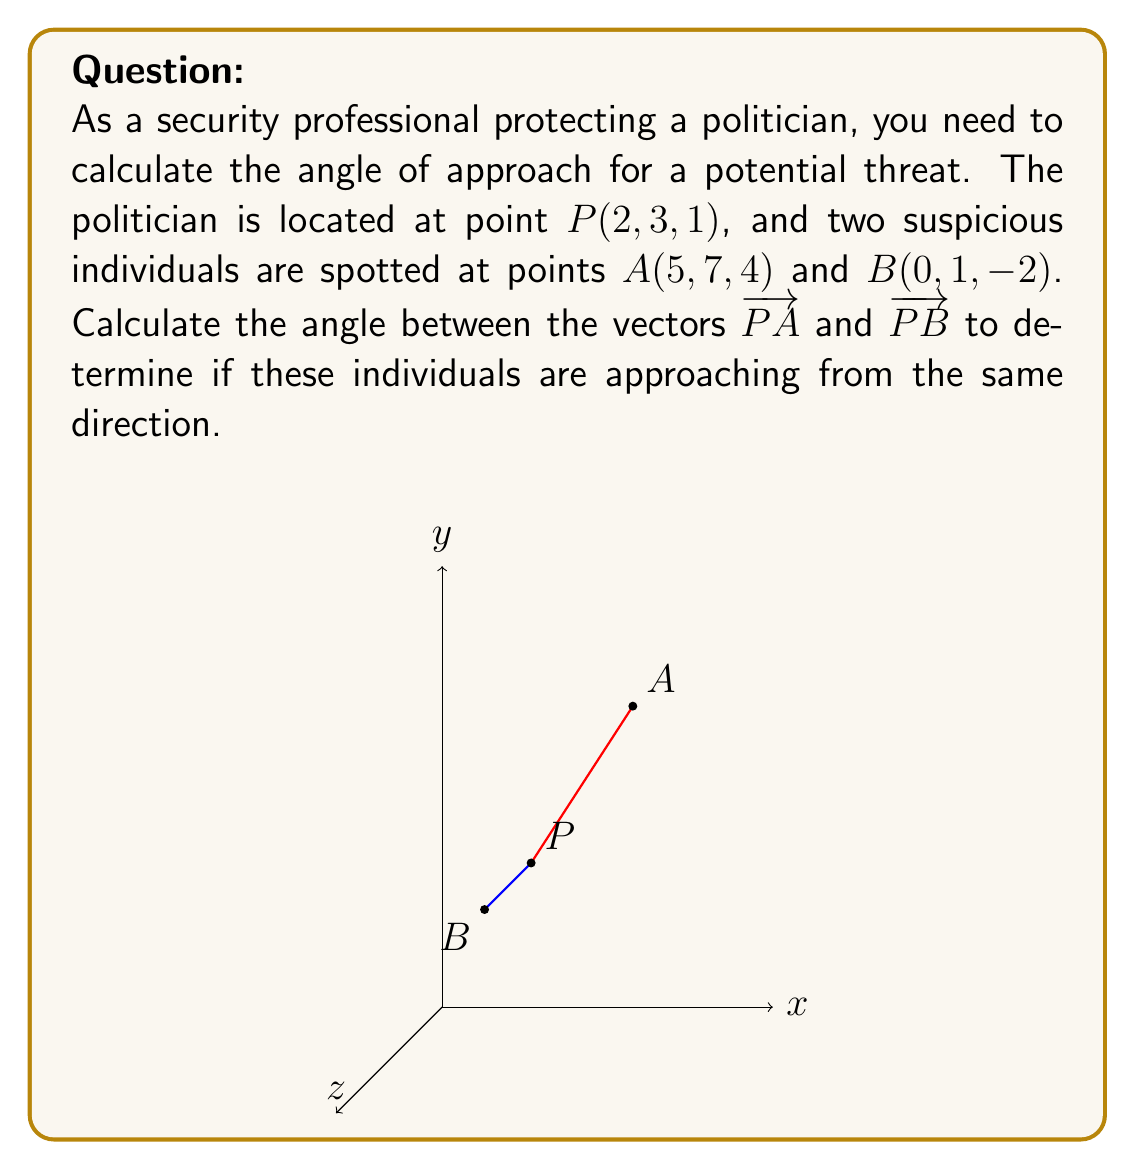Provide a solution to this math problem. To solve this problem, we'll follow these steps:

1) First, let's find the vectors PA and PB:
   PA = A - P = (5-2, 7-3, 4-1) = (3, 4, 3)
   PB = B - P = (0-2, 1-3, -2-1) = (-2, -2, -3)

2) The angle θ between two vectors a and b is given by the formula:
   $$\cos \theta = \frac{a \cdot b}{|a||b|}$$

3) Let's calculate the dot product PA · PB:
   PA · PB = 3(-2) + 4(-2) + 3(-3) = -6 - 8 - 9 = -23

4) Now, let's calculate the magnitudes of PA and PB:
   |PA| = $\sqrt{3^2 + 4^2 + 3^2}$ = $\sqrt{34}$
   |PB| = $\sqrt{(-2)^2 + (-2)^2 + (-3)^2}$ = $\sqrt{17}$

5) Substituting into the formula:
   $$\cos \theta = \frac{-23}{\sqrt{34}\sqrt{17}}$$

6) To find θ, we need to take the inverse cosine (arccos) of both sides:
   $$\theta = \arccos\left(\frac{-23}{\sqrt{34}\sqrt{17}}\right)$$

7) Using a calculator, we can evaluate this to get the angle in radians, then convert to degrees:
   θ ≈ 2.645 radians ≈ 151.5°
Answer: 151.5° 